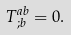<formula> <loc_0><loc_0><loc_500><loc_500>T ^ { a b } _ { \, ; b } = 0 .</formula> 